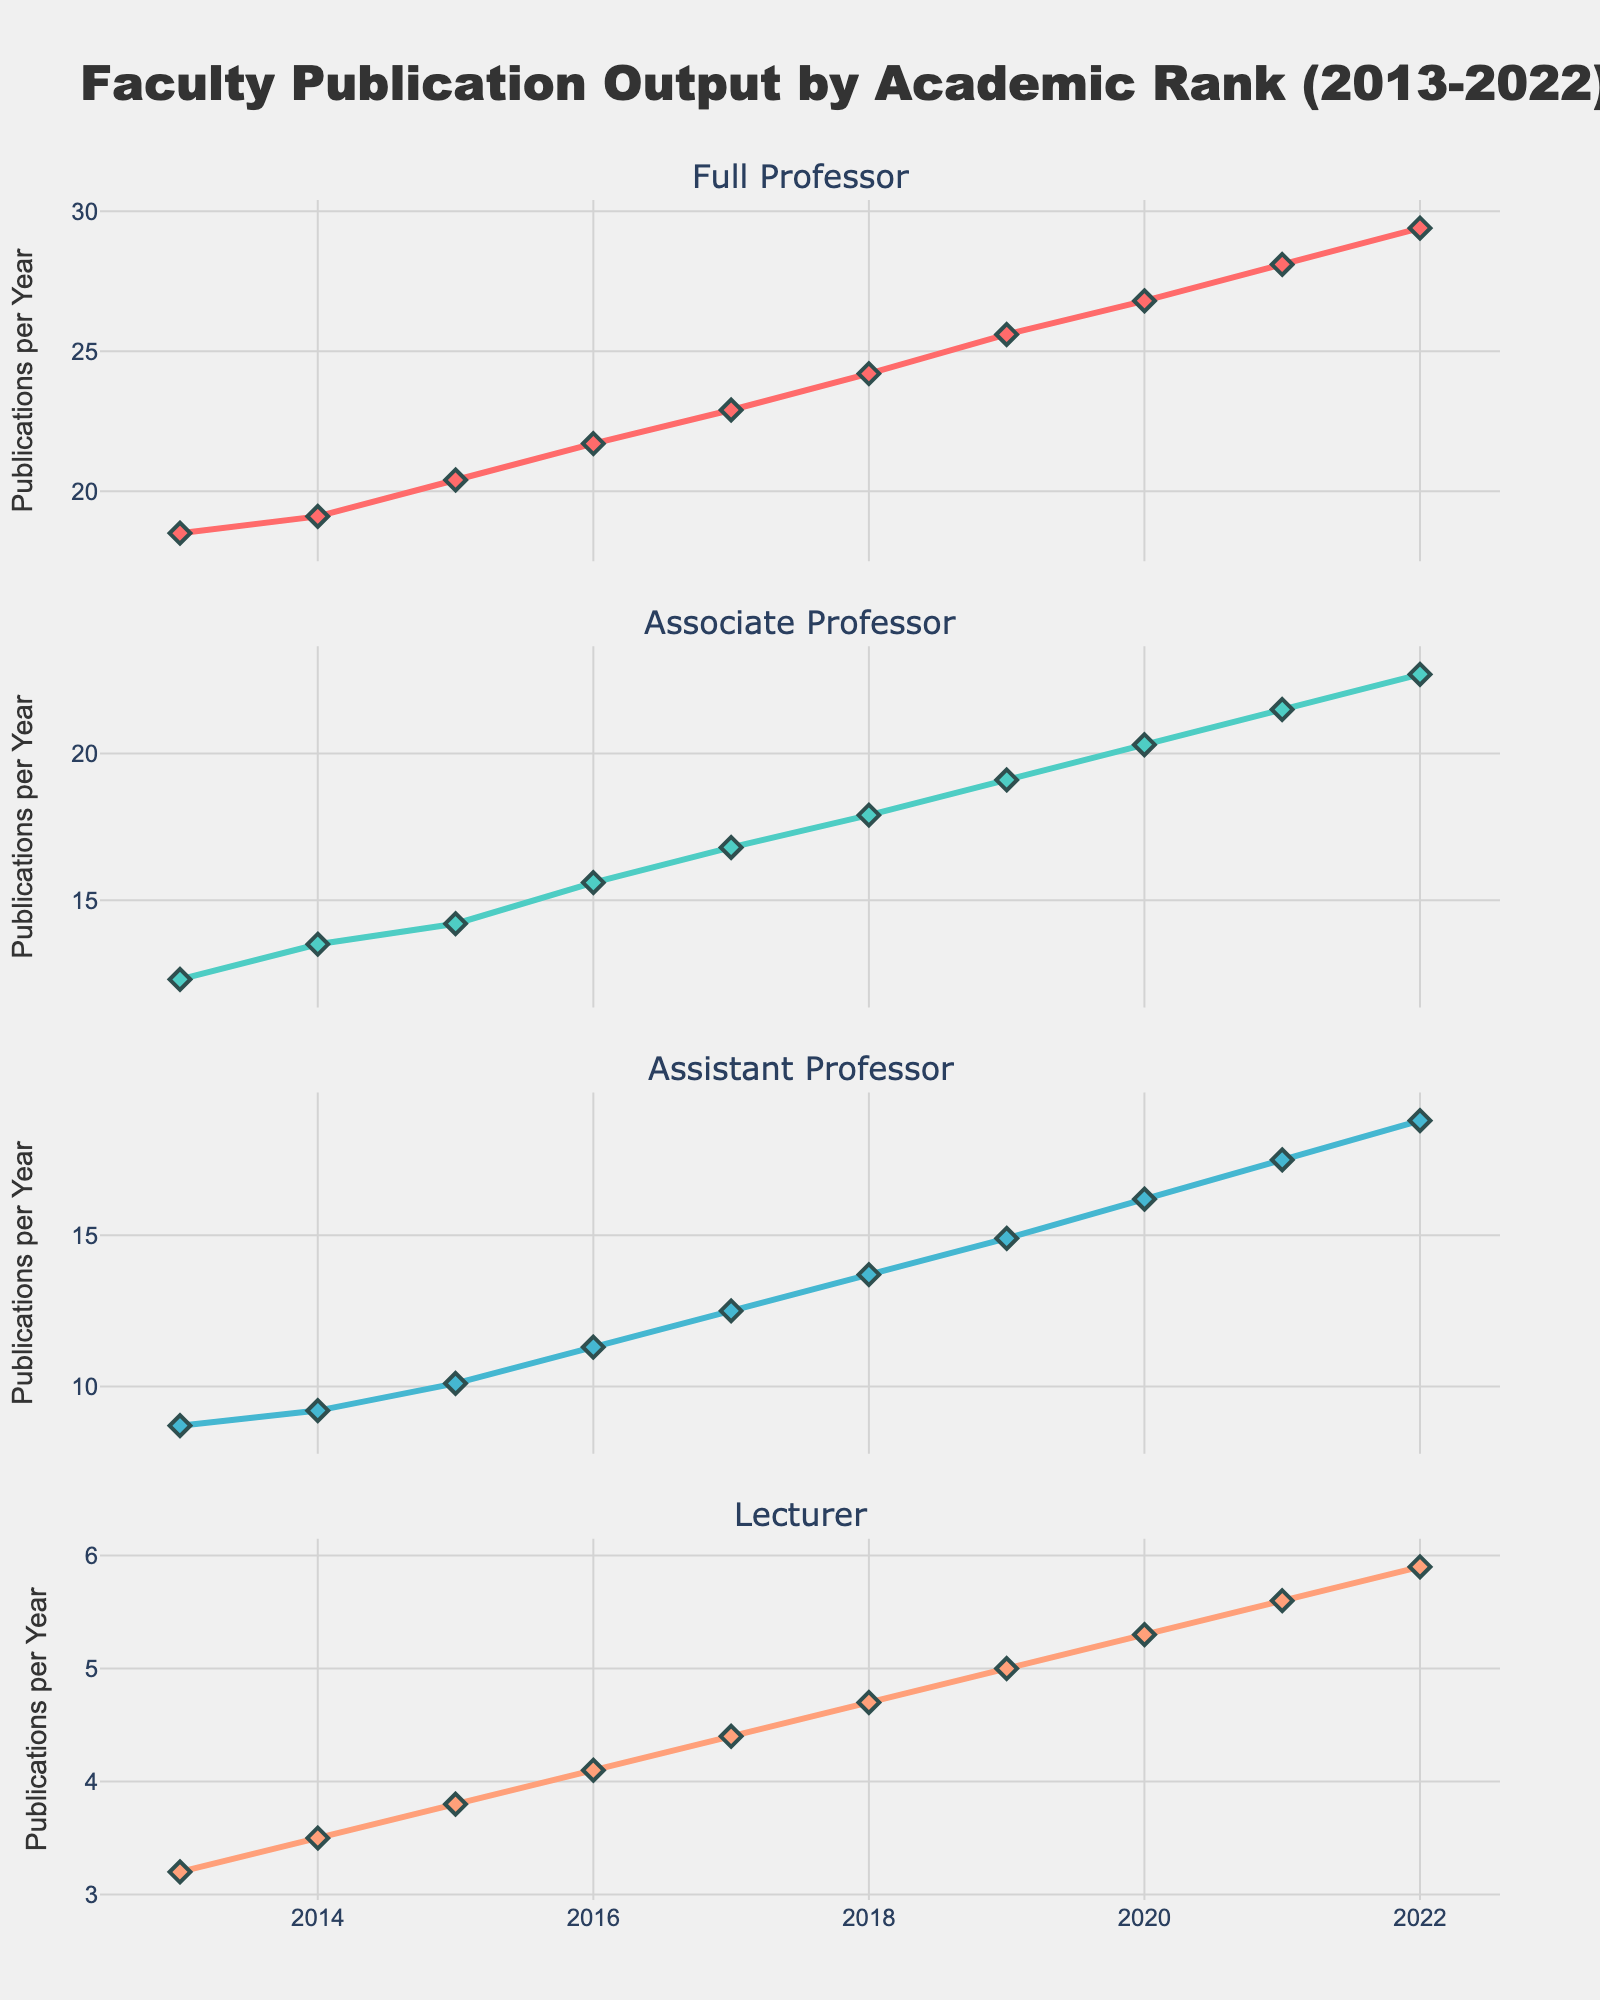How many subplots are included in this figure? There are a total of four subplots in the figure, each corresponding to a different academic rank (Full Professor, Associate Professor, Assistant Professor, Lecturer). This can be observed from the subplot titles.
Answer: Four What is the overall trend in publication output for Full Professors over the years 2013 to 2022? The publication output for Full Professors consistently increases from 18.5 publications in 2013 to 29.4 publications in 2022. This trend can be observed by looking at the line in the subplot for Full Professor.
Answer: Increasing Which academic rank had the highest publication output in 2022? By examining the values in the subplots for 2022, Full Professors had the highest publication output with 29.4 publications.
Answer: Full Professor Between which years did Associate Professors see the largest increase in publication output? By comparing the increments of publication outputs year-by-year for Associate Professors from the subplot, the largest increase happened between 2019 and 2020, from 19.1 to 20.3 publications.
Answer: 2019-2020 How many more publications did Assistant Professors produce in 2022 compared to 2013? The publication output for Assistant Professors in 2022 was 18.8, and in 2013 it was 8.7. Subtracting these values gives 18.8 - 8.7 = 10.1 additional publications in 2022 compared to 2013.
Answer: 10.1 Which rank's publication count has consistently increased each year over the period 2013-2022 without any decline? The line plots for each academic rank (Full Professor, Associate Professor, Assistant Professor, Lecturer) all show a consistent increase each year without any decline. This can be observed by the overall upward trend in all subplots.
Answer: All ranks What is the average annual increase in publication output for Lecturers between 2013 and 2022? Calculating the average annual increase involves finding the total increase over the period and dividing by the number of years: (5.9 - 3.2) / (2022 - 2013) = 2.7 / 9 ≈ 0.3 publications per year.
Answer: 0.3 In which year did Full Professors publication output surpass 25 publications per year? From the subplot for Full Professors, it can be seen that their publication output surpassed 25 in 2019 when the value reached 25.6.
Answer: 2019 On average, did the publication output of Associate Professors increase by more than 1 publication per year between 2013 and 2022? First, calculate the total increase for Associate Professors: 22.7 - 12.3 = 10.4. Then, average this over the given period: 10.4 / 9 = 1.155. Since 1.155 is greater than 1, the average increase is more than 1 publication per year.
Answer: Yes 